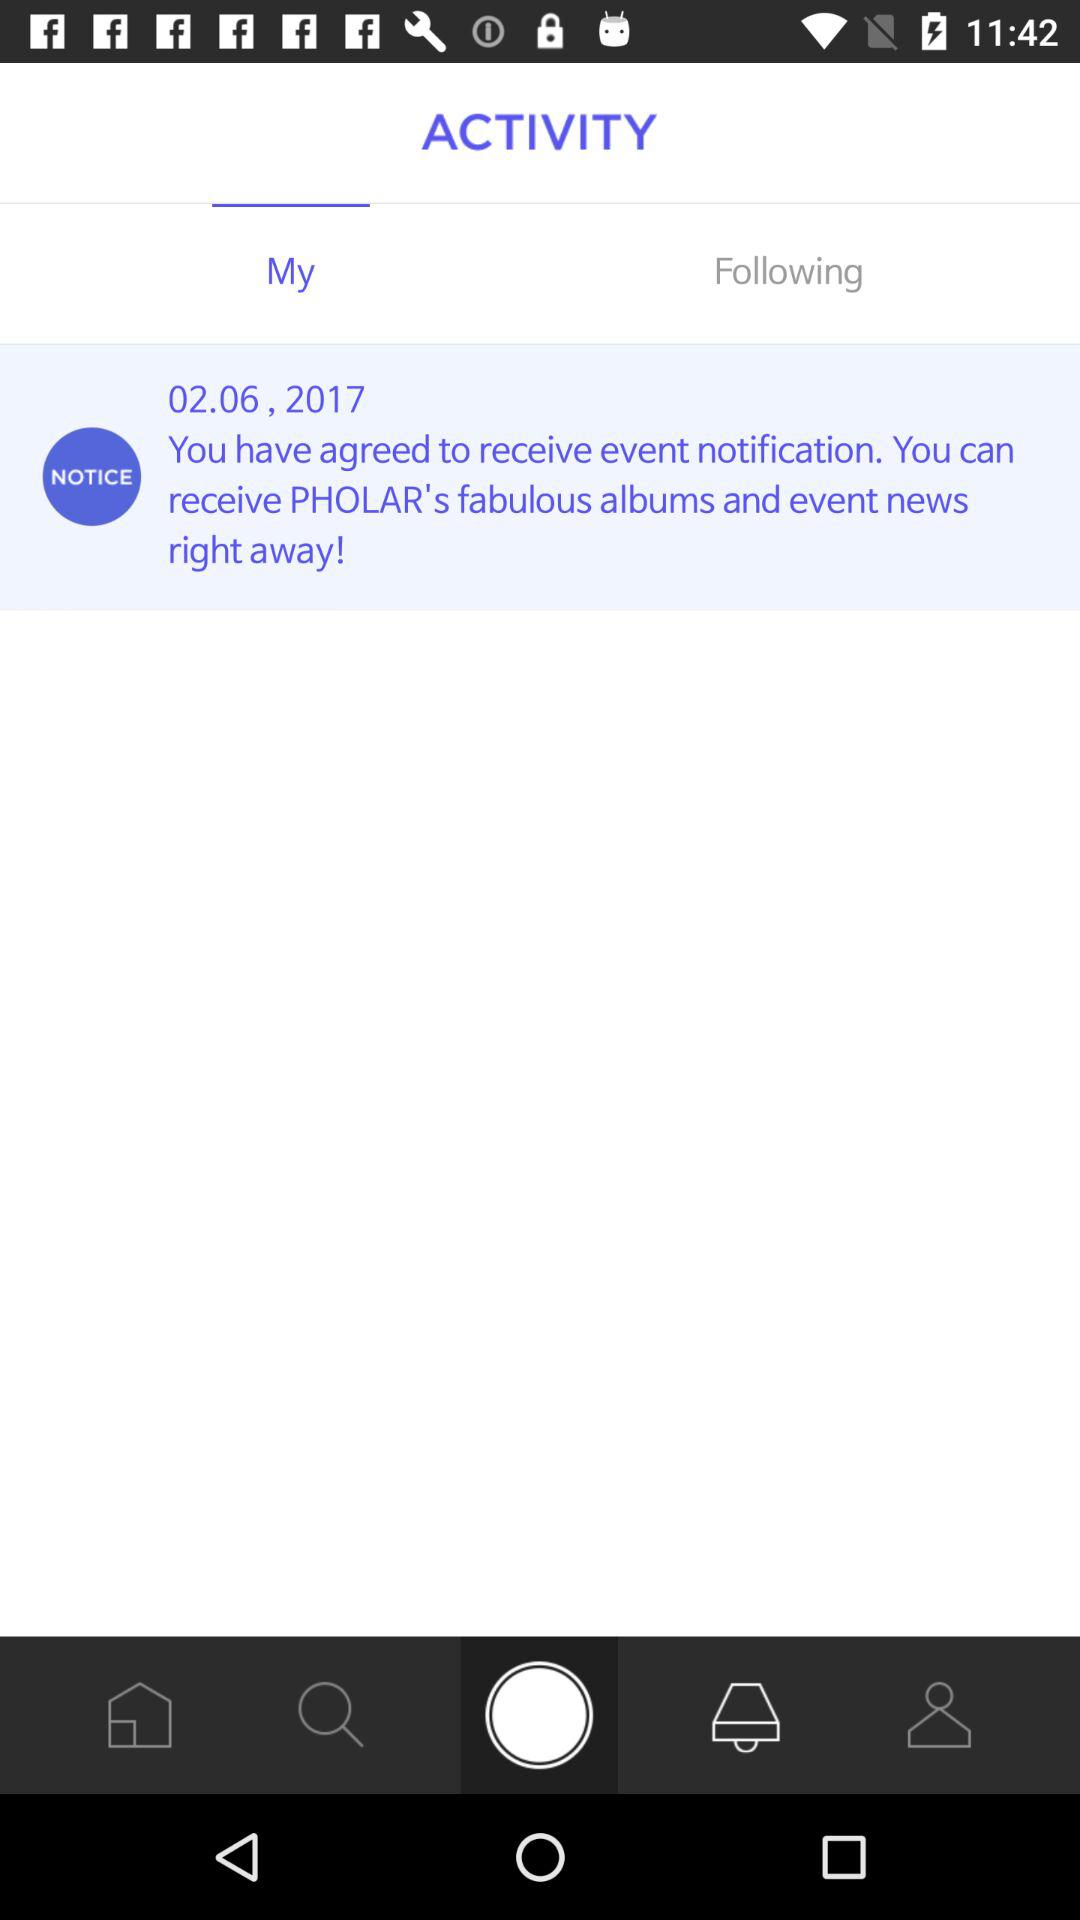How many people are following?
When the provided information is insufficient, respond with <no answer>. <no answer> 